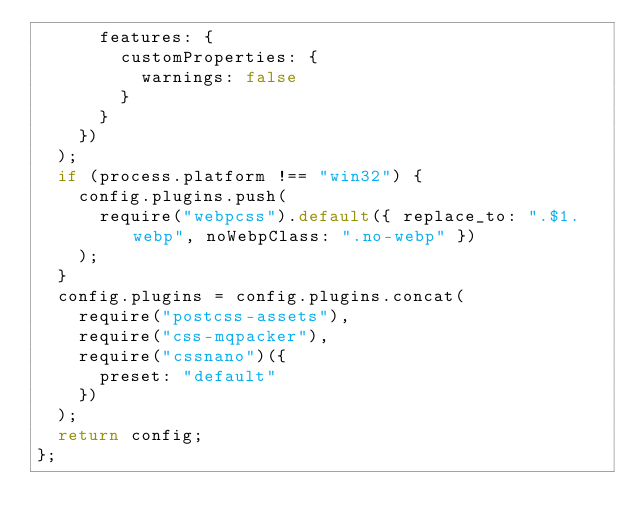<code> <loc_0><loc_0><loc_500><loc_500><_JavaScript_>      features: {
        customProperties: {
          warnings: false
        }
      }
    })
  );
  if (process.platform !== "win32") {
    config.plugins.push(
      require("webpcss").default({ replace_to: ".$1.webp", noWebpClass: ".no-webp" })
    );
  }
  config.plugins = config.plugins.concat(
    require("postcss-assets"),
    require("css-mqpacker"),
    require("cssnano")({
      preset: "default"
    })
  );
  return config;
};
</code> 